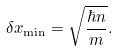<formula> <loc_0><loc_0><loc_500><loc_500>\delta x _ { \min } = \sqrt { \frac { \hbar { n } } { m } } .</formula> 